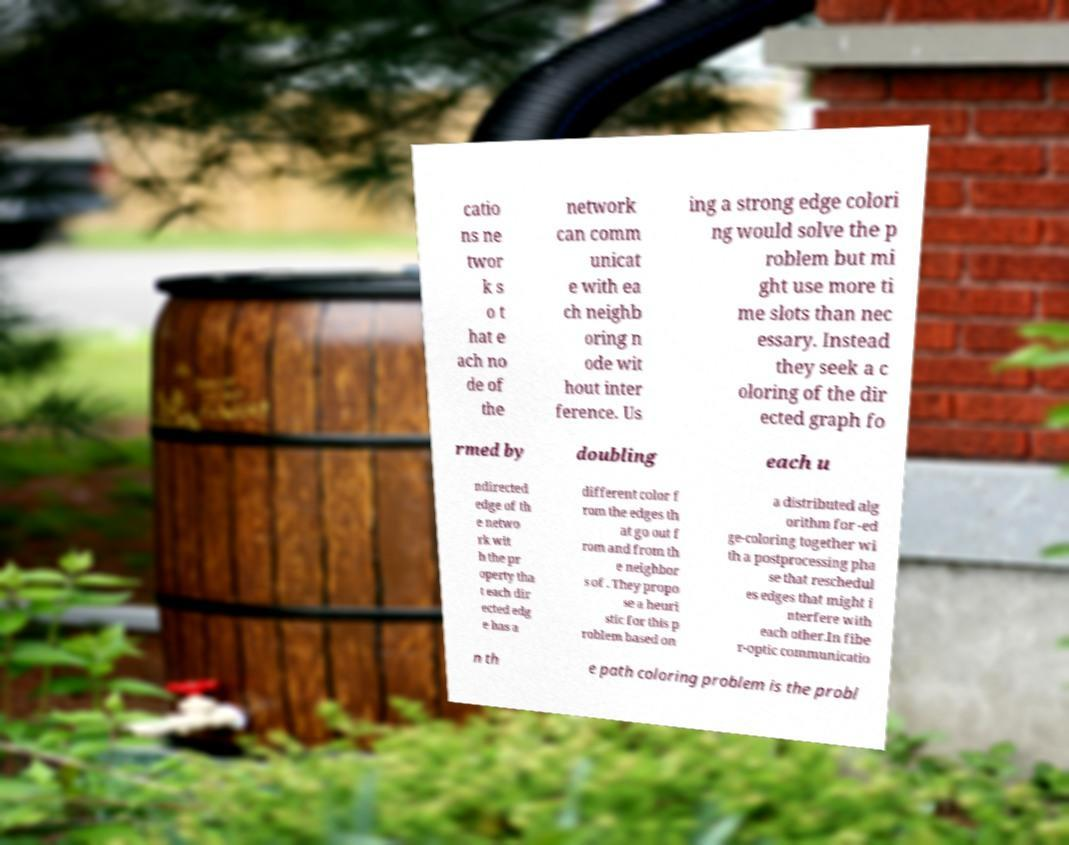Can you read and provide the text displayed in the image?This photo seems to have some interesting text. Can you extract and type it out for me? catio ns ne twor k s o t hat e ach no de of the network can comm unicat e with ea ch neighb oring n ode wit hout inter ference. Us ing a strong edge colori ng would solve the p roblem but mi ght use more ti me slots than nec essary. Instead they seek a c oloring of the dir ected graph fo rmed by doubling each u ndirected edge of th e netwo rk wit h the pr operty tha t each dir ected edg e has a different color f rom the edges th at go out f rom and from th e neighbor s of . They propo se a heuri stic for this p roblem based on a distributed alg orithm for -ed ge-coloring together wi th a postprocessing pha se that reschedul es edges that might i nterfere with each other.In fibe r-optic communicatio n th e path coloring problem is the probl 